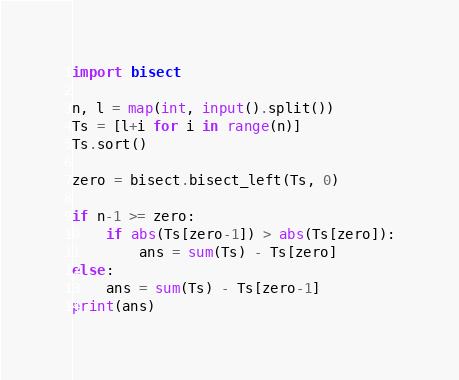<code> <loc_0><loc_0><loc_500><loc_500><_Python_>import bisect

n, l = map(int, input().split())
Ts = [l+i for i in range(n)]
Ts.sort()

zero = bisect.bisect_left(Ts, 0)

if n-1 >= zero:
    if abs(Ts[zero-1]) > abs(Ts[zero]):
        ans = sum(Ts) - Ts[zero]
else:
    ans = sum(Ts) - Ts[zero-1]
print(ans)


</code> 